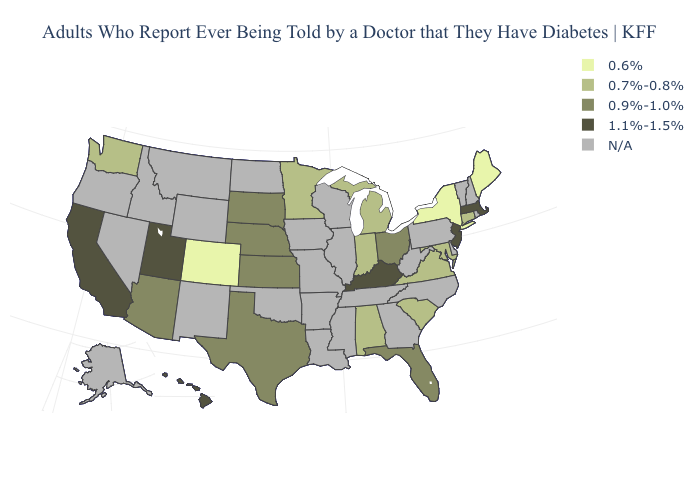Which states hav the highest value in the West?
Quick response, please. California, Hawaii, Utah. What is the value of California?
Keep it brief. 1.1%-1.5%. Name the states that have a value in the range 1.1%-1.5%?
Give a very brief answer. California, Hawaii, Kentucky, Massachusetts, New Jersey, Utah. What is the value of Florida?
Quick response, please. 0.9%-1.0%. Name the states that have a value in the range 0.9%-1.0%?
Answer briefly. Arizona, Florida, Kansas, Nebraska, Ohio, South Dakota, Texas. Name the states that have a value in the range 1.1%-1.5%?
Be succinct. California, Hawaii, Kentucky, Massachusetts, New Jersey, Utah. What is the highest value in the West ?
Write a very short answer. 1.1%-1.5%. What is the lowest value in states that border Oregon?
Give a very brief answer. 0.7%-0.8%. What is the value of Maryland?
Be succinct. 0.7%-0.8%. Name the states that have a value in the range 1.1%-1.5%?
Keep it brief. California, Hawaii, Kentucky, Massachusetts, New Jersey, Utah. What is the value of West Virginia?
Write a very short answer. N/A. Does Connecticut have the highest value in the Northeast?
Keep it brief. No. What is the value of Oklahoma?
Concise answer only. N/A. Name the states that have a value in the range 0.9%-1.0%?
Give a very brief answer. Arizona, Florida, Kansas, Nebraska, Ohio, South Dakota, Texas. 